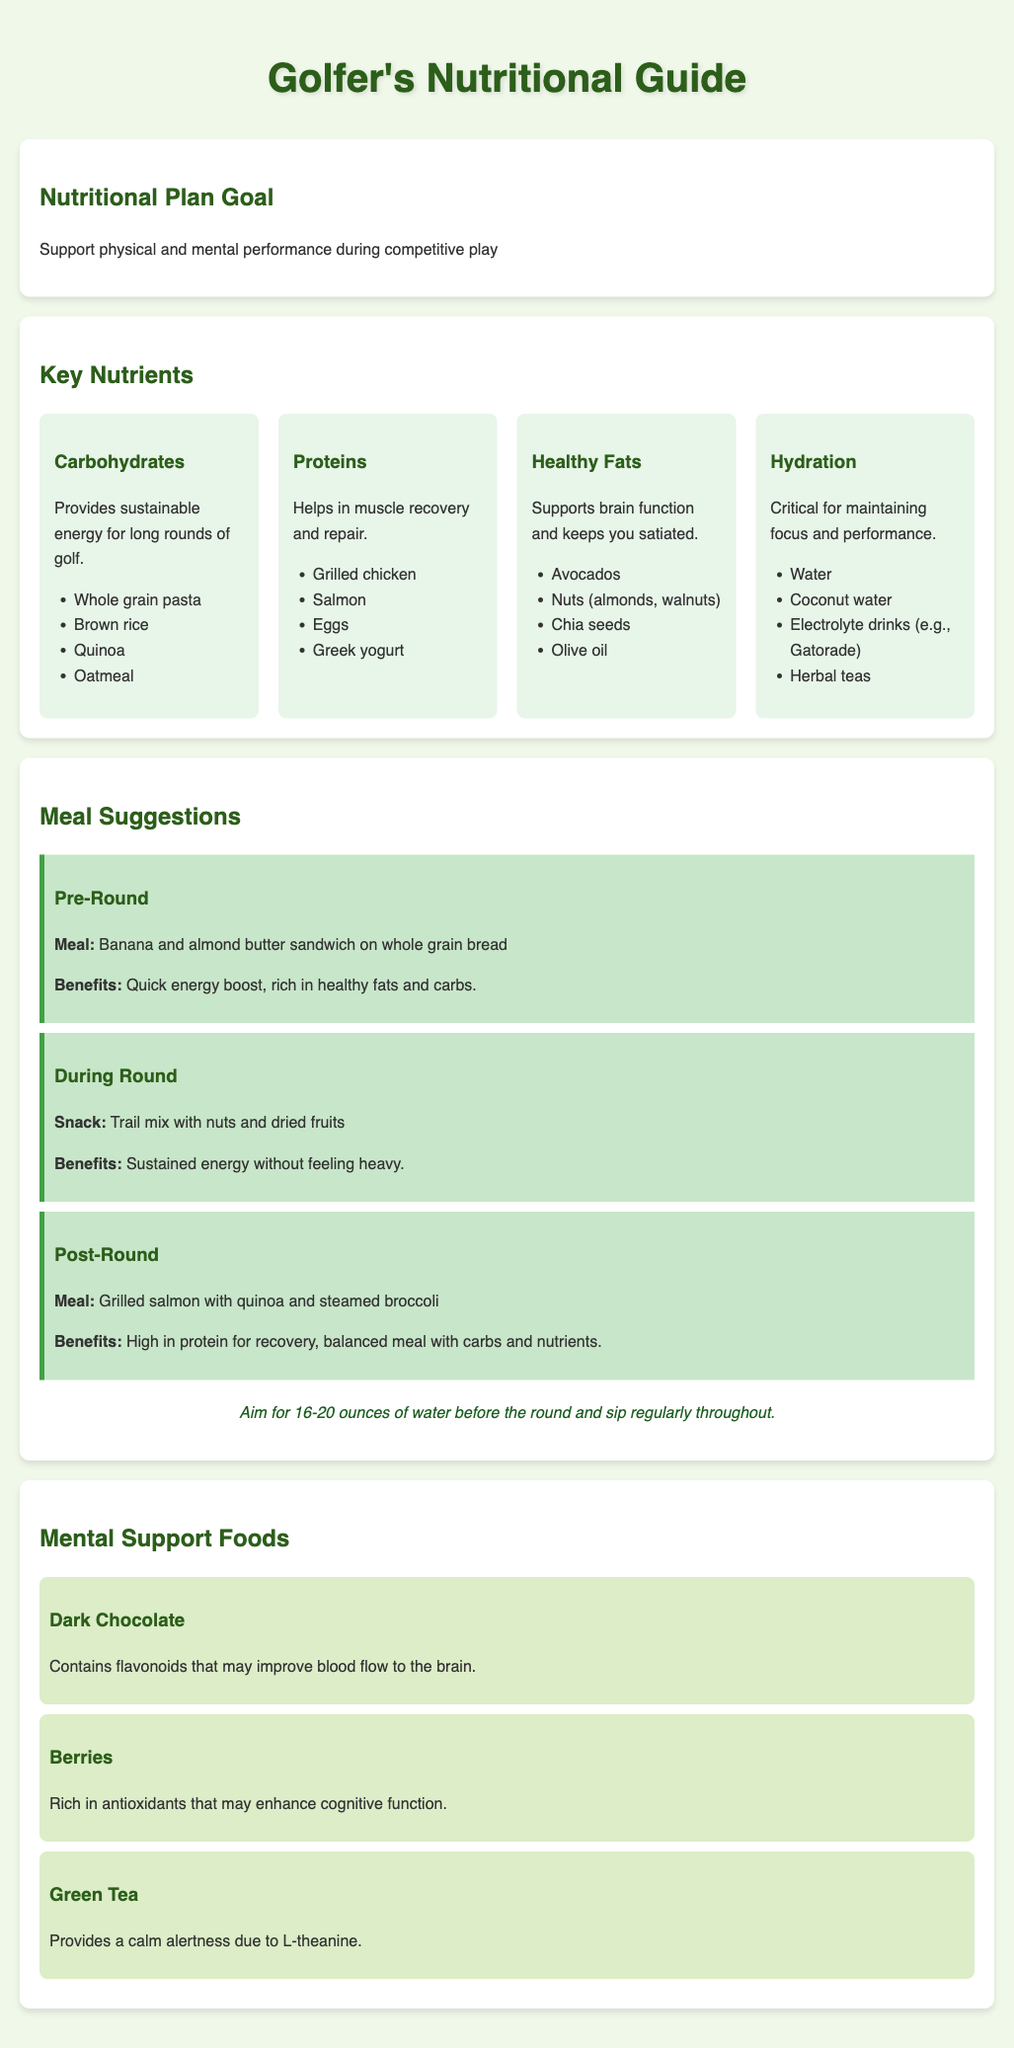What is the main goal of the nutritional plan? The goal is to support physical and mental performance during competitive play.
Answer: Support physical and mental performance during competitive play Which nutrient is critical for maintaining focus? The document states that hydration is critical for maintaining focus and performance.
Answer: Hydration Name one meal suggested for after a round. The document lists grilled salmon with quinoa and steamed broccoli as a post-round meal.
Answer: Grilled salmon with quinoa and steamed broccoli What is a suggested snack during a round? A suggested snack during a round is trail mix with nuts and dried fruits.
Answer: Trail mix with nuts and dried fruits What do dark chocolate and berries have in common, according to mental support foods? Both dark chocolate and berries are mentioned as foods that can enhance cognitive function.
Answer: Enhance cognitive function How many ounces of water should be consumed before a round? The document recommends aiming for 16-20 ounces of water before the round.
Answer: 16-20 ounces What type of fats does the nutritional guide recommend? The guide recommends healthy fats as part of the nutritional plan.
Answer: Healthy Fats What specific benefit does green tea provide? Green tea provides a calm alertness due to L-theanine.
Answer: Calm alertness due to L-theanine What are two examples of carbohydrates suggested? The examples of carbohydrates suggested include whole grain pasta and brown rice.
Answer: Whole grain pasta, brown rice 